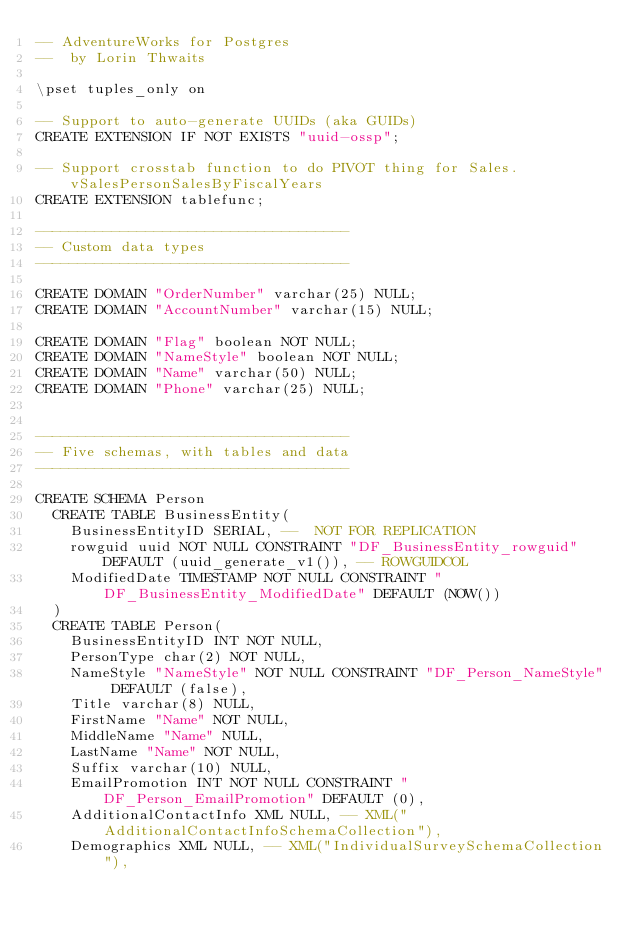<code> <loc_0><loc_0><loc_500><loc_500><_SQL_>-- AdventureWorks for Postgres
--  by Lorin Thwaits

\pset tuples_only on

-- Support to auto-generate UUIDs (aka GUIDs)
CREATE EXTENSION IF NOT EXISTS "uuid-ossp";

-- Support crosstab function to do PIVOT thing for Sales.vSalesPersonSalesByFiscalYears
CREATE EXTENSION tablefunc;

-------------------------------------
-- Custom data types
-------------------------------------

CREATE DOMAIN "OrderNumber" varchar(25) NULL;
CREATE DOMAIN "AccountNumber" varchar(15) NULL;

CREATE DOMAIN "Flag" boolean NOT NULL;
CREATE DOMAIN "NameStyle" boolean NOT NULL;
CREATE DOMAIN "Name" varchar(50) NULL;
CREATE DOMAIN "Phone" varchar(25) NULL;


-------------------------------------
-- Five schemas, with tables and data
-------------------------------------

CREATE SCHEMA Person
  CREATE TABLE BusinessEntity(
    BusinessEntityID SERIAL, --  NOT FOR REPLICATION
    rowguid uuid NOT NULL CONSTRAINT "DF_BusinessEntity_rowguid" DEFAULT (uuid_generate_v1()), -- ROWGUIDCOL
    ModifiedDate TIMESTAMP NOT NULL CONSTRAINT "DF_BusinessEntity_ModifiedDate" DEFAULT (NOW())
  )
  CREATE TABLE Person(
    BusinessEntityID INT NOT NULL,
    PersonType char(2) NOT NULL,
    NameStyle "NameStyle" NOT NULL CONSTRAINT "DF_Person_NameStyle" DEFAULT (false),
    Title varchar(8) NULL,
    FirstName "Name" NOT NULL,
    MiddleName "Name" NULL,
    LastName "Name" NOT NULL,
    Suffix varchar(10) NULL,
    EmailPromotion INT NOT NULL CONSTRAINT "DF_Person_EmailPromotion" DEFAULT (0),
    AdditionalContactInfo XML NULL, -- XML("AdditionalContactInfoSchemaCollection"),
    Demographics XML NULL, -- XML("IndividualSurveySchemaCollection"),</code> 